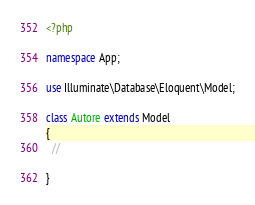Convert code to text. <code><loc_0><loc_0><loc_500><loc_500><_PHP_><?php

namespace App;

use Illuminate\Database\Eloquent\Model;

class Autore extends Model
{
  //
    
}
</code> 